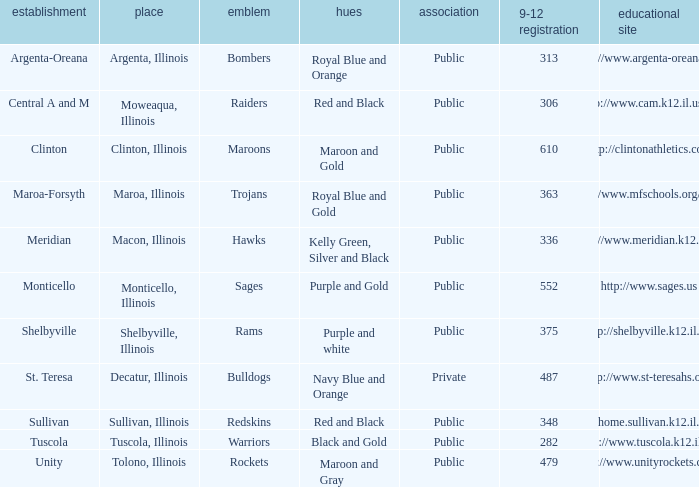What colors can you see players from Tolono, Illinois wearing? Maroon and Gray. 